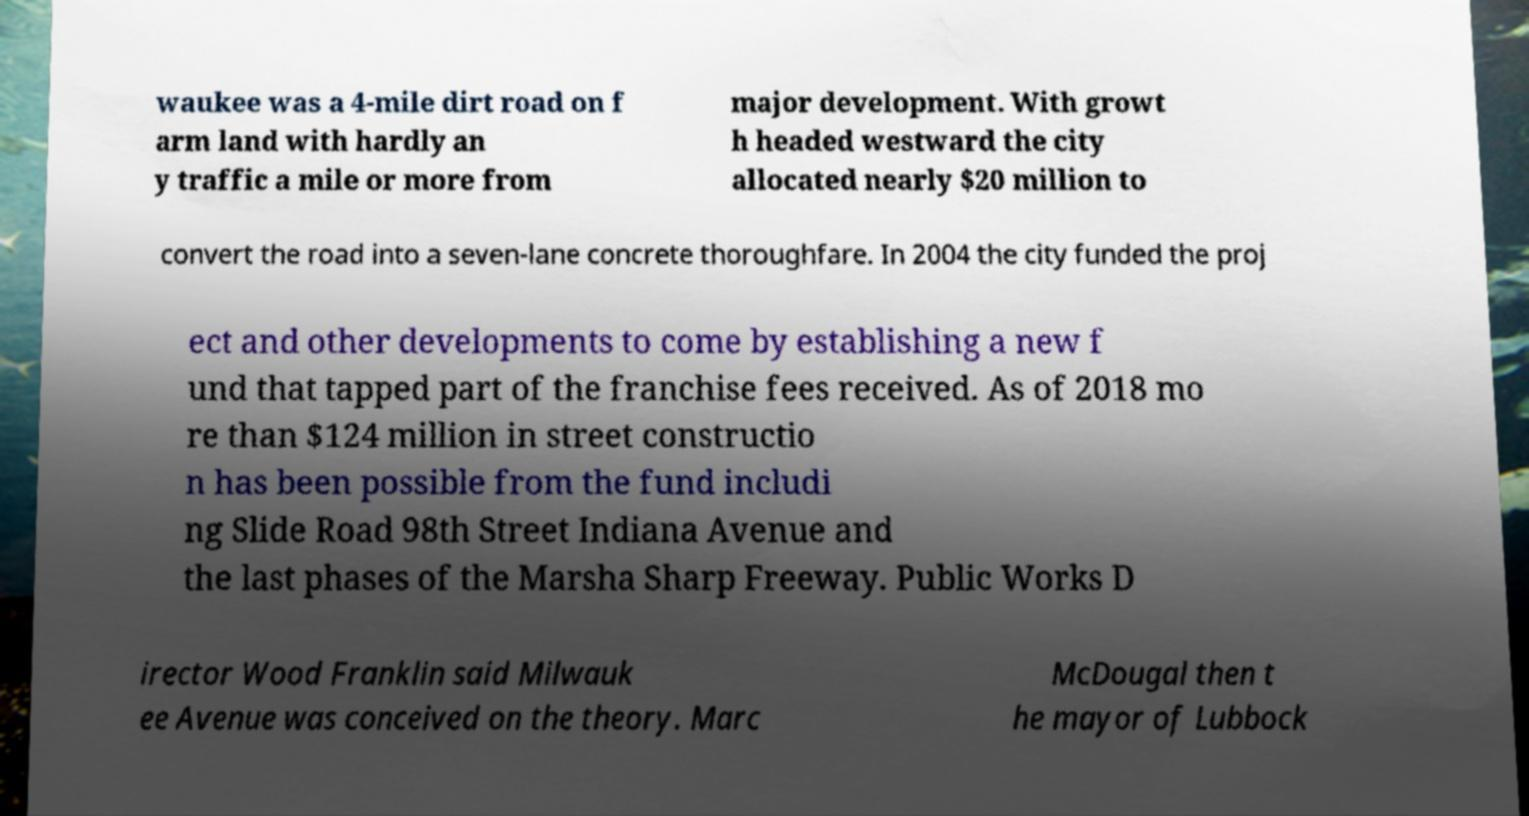Can you accurately transcribe the text from the provided image for me? waukee was a 4-mile dirt road on f arm land with hardly an y traffic a mile or more from major development. With growt h headed westward the city allocated nearly $20 million to convert the road into a seven-lane concrete thoroughfare. In 2004 the city funded the proj ect and other developments to come by establishing a new f und that tapped part of the franchise fees received. As of 2018 mo re than $124 million in street constructio n has been possible from the fund includi ng Slide Road 98th Street Indiana Avenue and the last phases of the Marsha Sharp Freeway. Public Works D irector Wood Franklin said Milwauk ee Avenue was conceived on the theory. Marc McDougal then t he mayor of Lubbock 